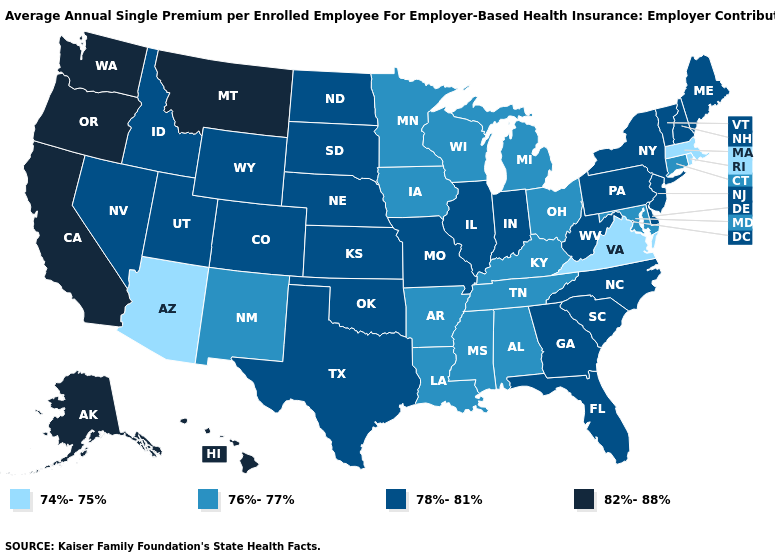Name the states that have a value in the range 76%-77%?
Give a very brief answer. Alabama, Arkansas, Connecticut, Iowa, Kentucky, Louisiana, Maryland, Michigan, Minnesota, Mississippi, New Mexico, Ohio, Tennessee, Wisconsin. What is the value of Iowa?
Keep it brief. 76%-77%. What is the lowest value in states that border Rhode Island?
Be succinct. 74%-75%. What is the value of Maryland?
Keep it brief. 76%-77%. Which states have the highest value in the USA?
Keep it brief. Alaska, California, Hawaii, Montana, Oregon, Washington. What is the value of Louisiana?
Quick response, please. 76%-77%. What is the value of Kentucky?
Write a very short answer. 76%-77%. Does Nebraska have the same value as South Dakota?
Answer briefly. Yes. Does Colorado have a higher value than Connecticut?
Keep it brief. Yes. What is the value of Massachusetts?
Concise answer only. 74%-75%. What is the highest value in the USA?
Be succinct. 82%-88%. What is the value of Texas?
Quick response, please. 78%-81%. What is the value of West Virginia?
Answer briefly. 78%-81%. Name the states that have a value in the range 76%-77%?
Write a very short answer. Alabama, Arkansas, Connecticut, Iowa, Kentucky, Louisiana, Maryland, Michigan, Minnesota, Mississippi, New Mexico, Ohio, Tennessee, Wisconsin. What is the value of Nebraska?
Concise answer only. 78%-81%. 